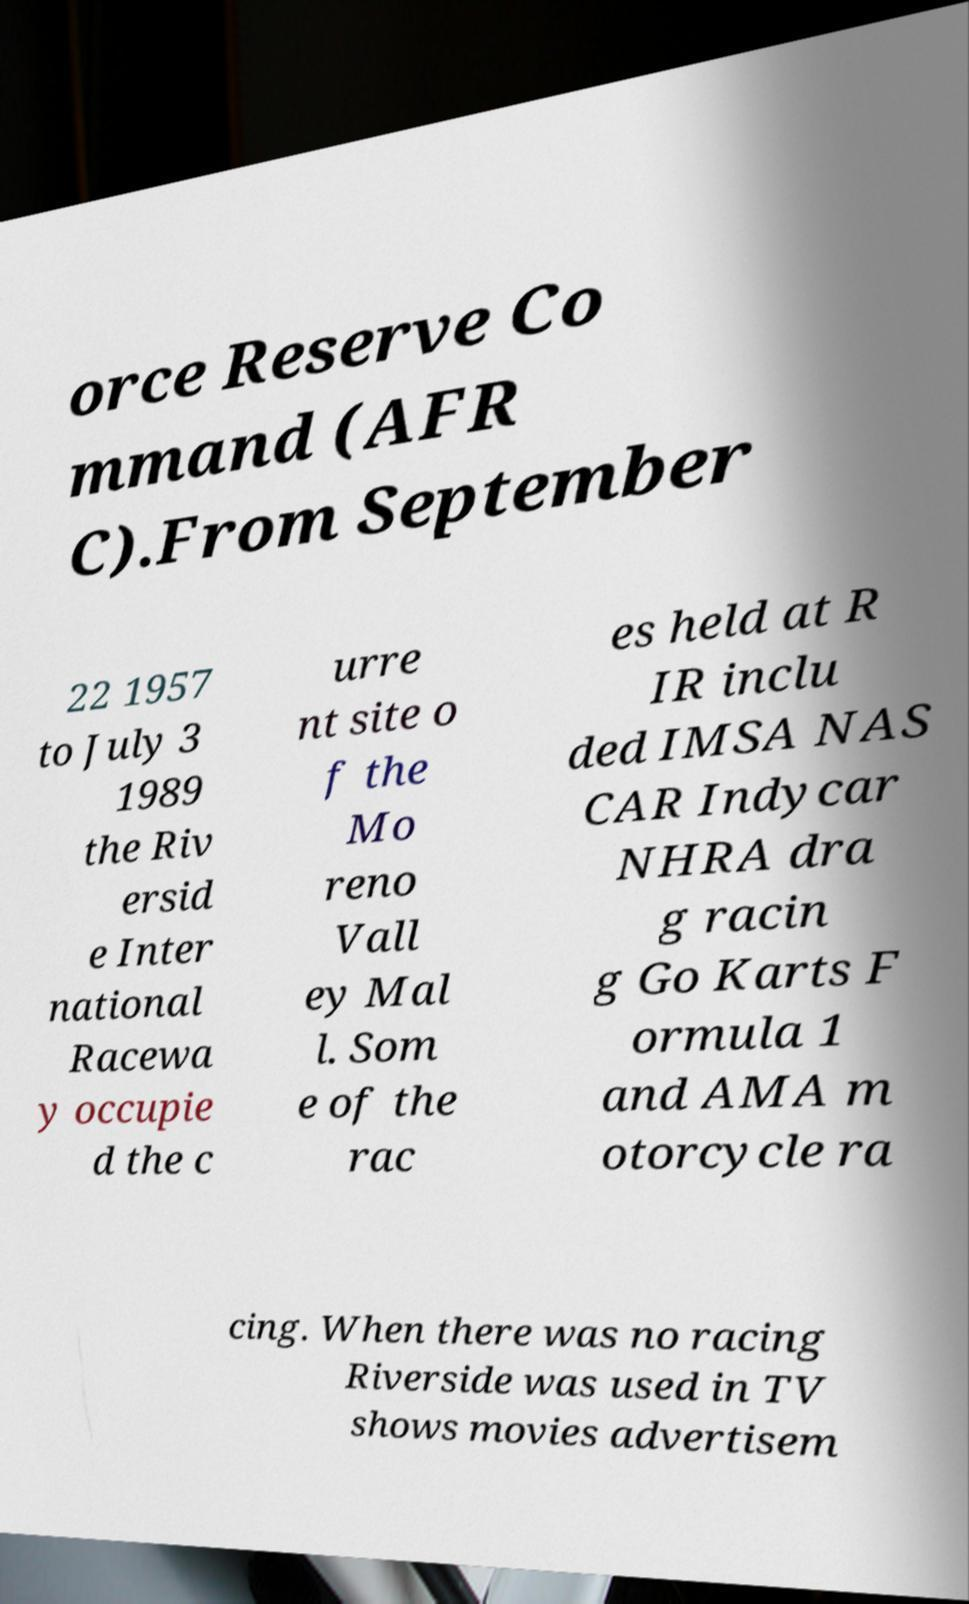What messages or text are displayed in this image? I need them in a readable, typed format. orce Reserve Co mmand (AFR C).From September 22 1957 to July 3 1989 the Riv ersid e Inter national Racewa y occupie d the c urre nt site o f the Mo reno Vall ey Mal l. Som e of the rac es held at R IR inclu ded IMSA NAS CAR Indycar NHRA dra g racin g Go Karts F ormula 1 and AMA m otorcycle ra cing. When there was no racing Riverside was used in TV shows movies advertisem 